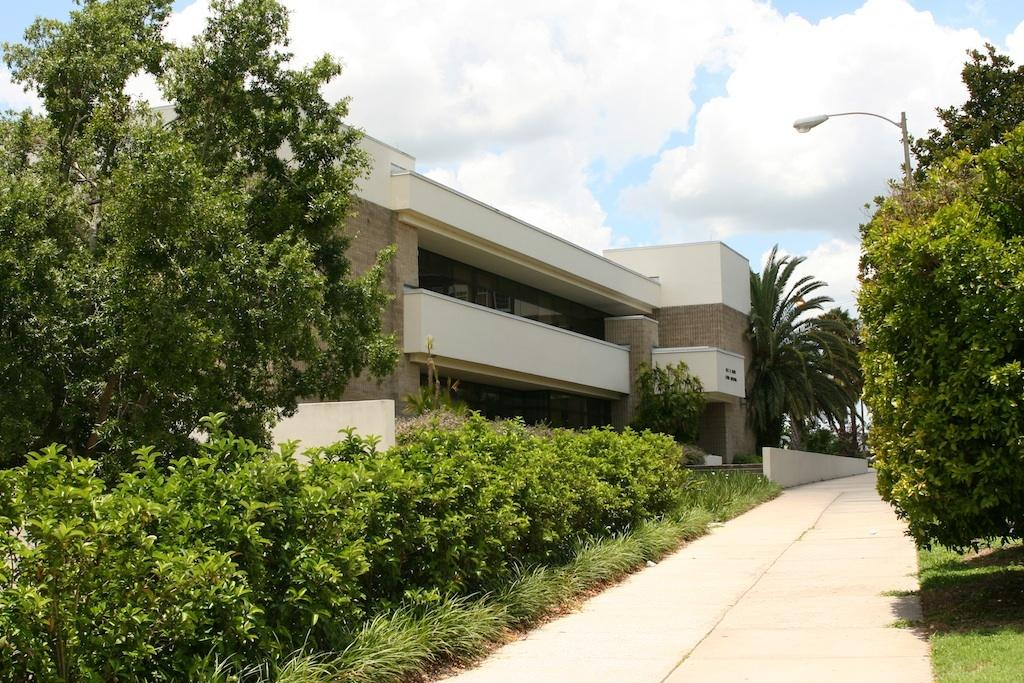What is the main feature in the middle of the image? There is a path in the middle of the image. What can be seen on either side of the path? Plants are present on either side of the path. What is visible in the background on the left side? There is a building in the background on the left side. What is visible above the building? The sky is visible above the building. What can be observed in the sky? Clouds are present in the sky. Can you see the carpenter working on the icicle in the image? There is no carpenter or icicle present in the image. 